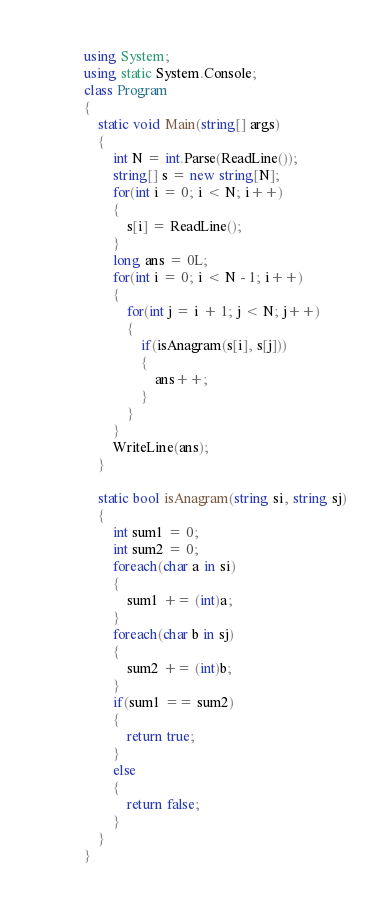Convert code to text. <code><loc_0><loc_0><loc_500><loc_500><_C#_>using System;
using static System.Console;
class Program
{
    static void Main(string[] args)
    {
        int N = int.Parse(ReadLine());
        string[] s = new string[N];
        for(int i = 0; i < N; i++)
        {
            s[i] = ReadLine();
        }
        long ans = 0L;
        for(int i = 0; i < N - 1; i++)
        {
            for(int j = i + 1; j < N; j++)
            {
                if(isAnagram(s[i], s[j]))
                {
                    ans++;
                }
            }
        }
        WriteLine(ans);
    }

    static bool isAnagram(string si, string sj)
    {
        int sum1 = 0;
        int sum2 = 0;
        foreach(char a in si)
        {
            sum1 += (int)a;
        }
        foreach(char b in sj)
        {
            sum2 += (int)b;
        }
        if(sum1 == sum2)
        {
            return true;
        }
        else
        {
            return false;
        }
    }
}</code> 